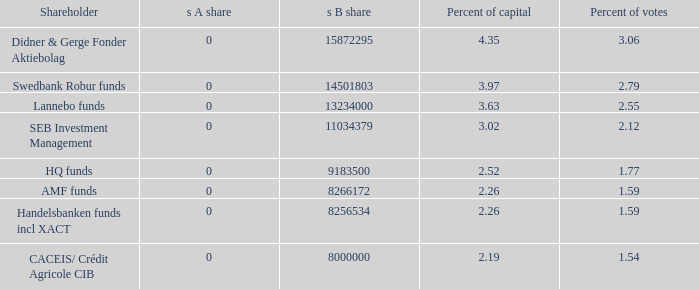12 percent of voting power? 11034379.0. 